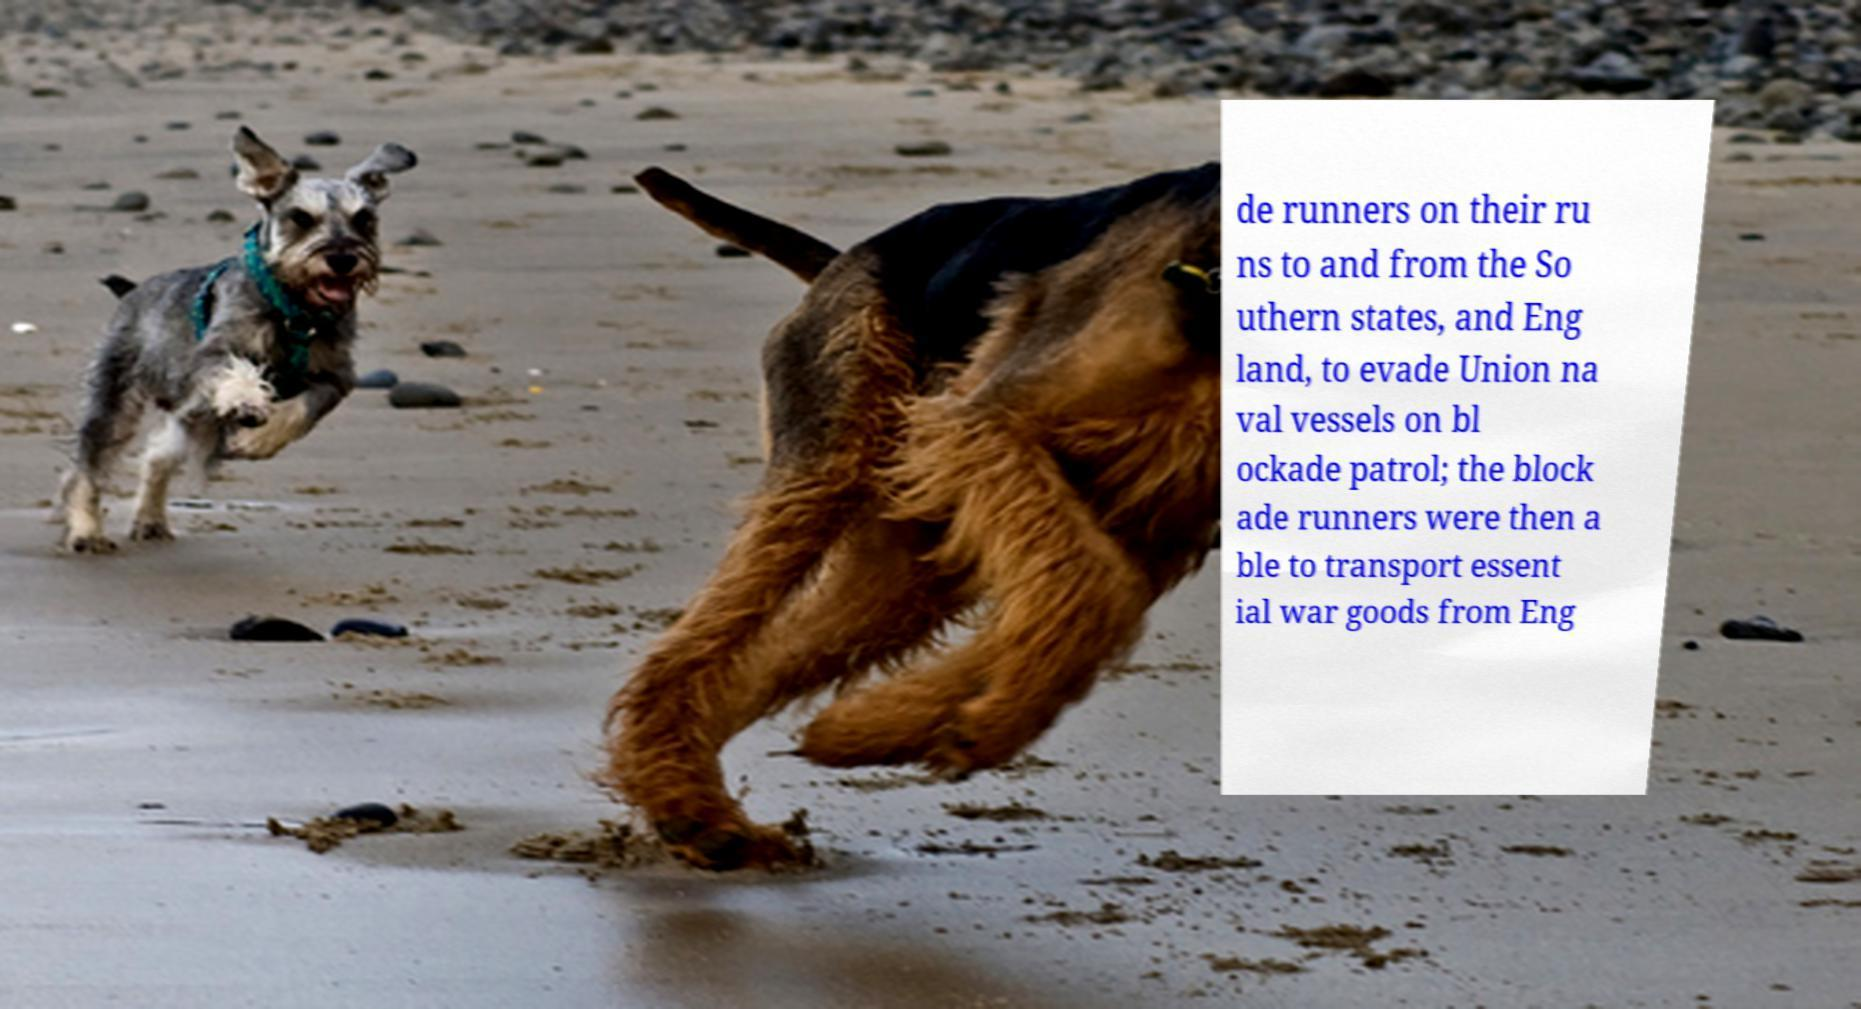Can you read and provide the text displayed in the image?This photo seems to have some interesting text. Can you extract and type it out for me? de runners on their ru ns to and from the So uthern states, and Eng land, to evade Union na val vessels on bl ockade patrol; the block ade runners were then a ble to transport essent ial war goods from Eng 